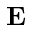Convert formula to latex. <formula><loc_0><loc_0><loc_500><loc_500>\mathbf E</formula> 